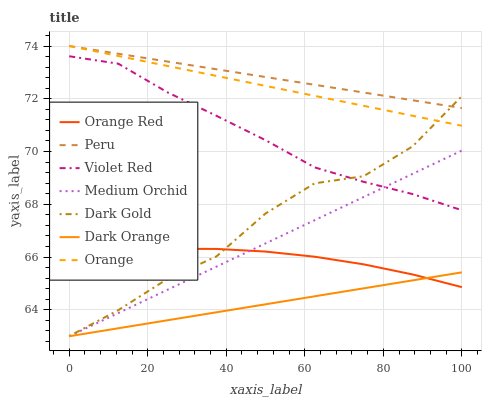Does Dark Orange have the minimum area under the curve?
Answer yes or no. Yes. Does Peru have the maximum area under the curve?
Answer yes or no. Yes. Does Violet Red have the minimum area under the curve?
Answer yes or no. No. Does Violet Red have the maximum area under the curve?
Answer yes or no. No. Is Medium Orchid the smoothest?
Answer yes or no. Yes. Is Dark Gold the roughest?
Answer yes or no. Yes. Is Violet Red the smoothest?
Answer yes or no. No. Is Violet Red the roughest?
Answer yes or no. No. Does Dark Orange have the lowest value?
Answer yes or no. Yes. Does Violet Red have the lowest value?
Answer yes or no. No. Does Orange have the highest value?
Answer yes or no. Yes. Does Violet Red have the highest value?
Answer yes or no. No. Is Violet Red less than Peru?
Answer yes or no. Yes. Is Dark Gold greater than Medium Orchid?
Answer yes or no. Yes. Does Violet Red intersect Medium Orchid?
Answer yes or no. Yes. Is Violet Red less than Medium Orchid?
Answer yes or no. No. Is Violet Red greater than Medium Orchid?
Answer yes or no. No. Does Violet Red intersect Peru?
Answer yes or no. No. 